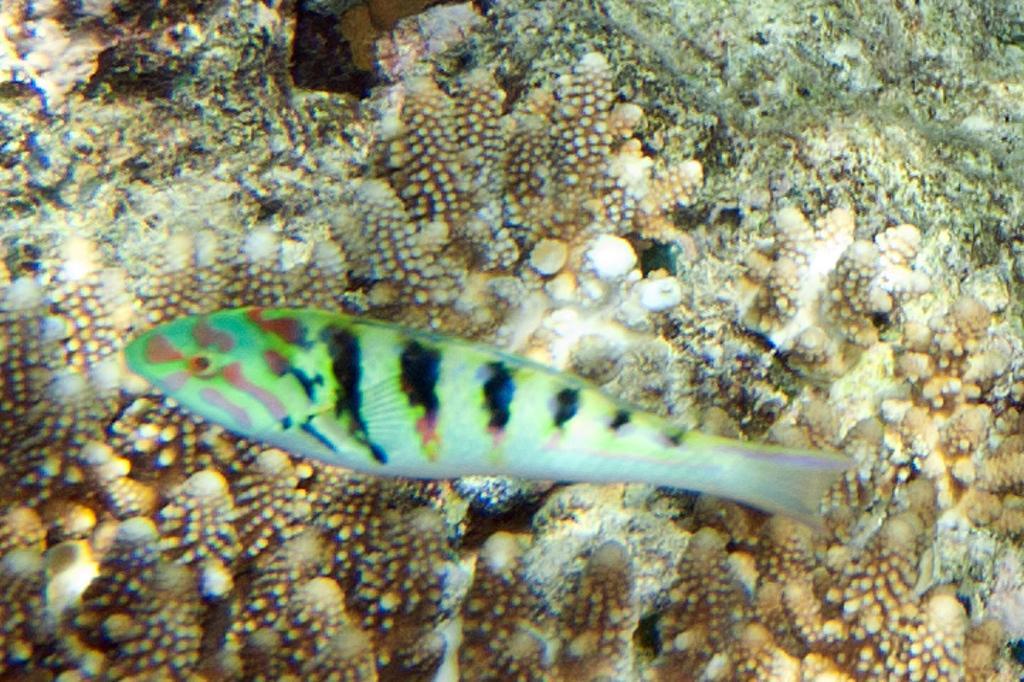How would you summarize this image in a sentence or two? In this image I can see a green color fish. 